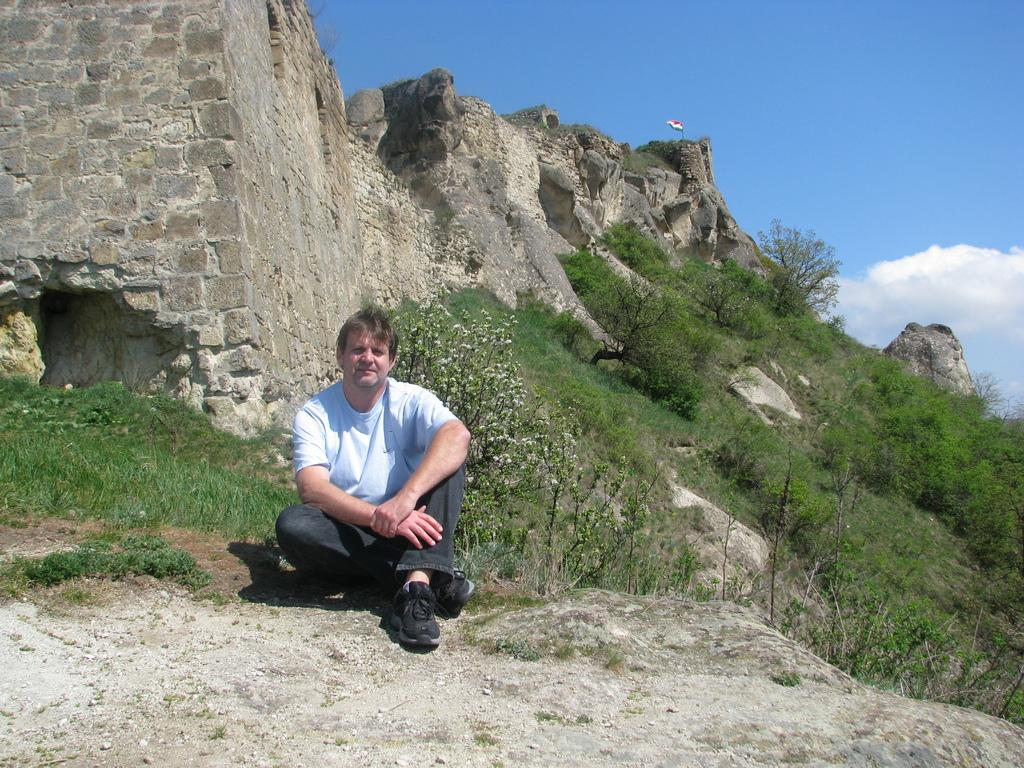What is the person in the image doing? The person is sitting on a rock in the image. What can be seen in the background of the image? There are trees, a flag, a hill, and the sky visible in the background of the image. Is the person sitting on a rock near the seashore in the image? There is no indication of a seashore in the image; it only shows a person sitting on a rock with trees, a flag, a hill, and the sky in the background. 